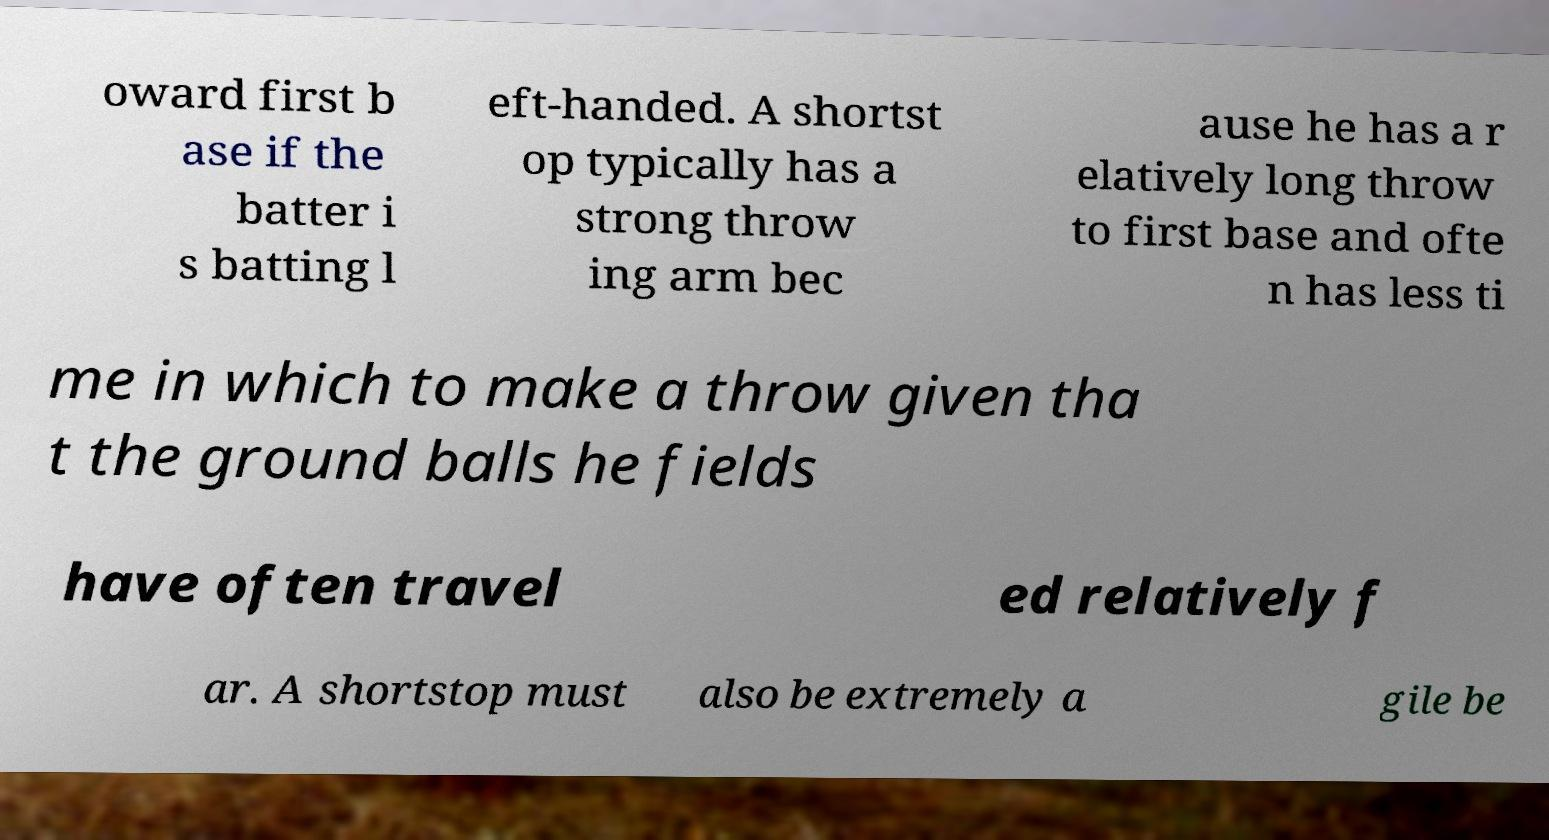Please identify and transcribe the text found in this image. oward first b ase if the batter i s batting l eft-handed. A shortst op typically has a strong throw ing arm bec ause he has a r elatively long throw to first base and ofte n has less ti me in which to make a throw given tha t the ground balls he fields have often travel ed relatively f ar. A shortstop must also be extremely a gile be 